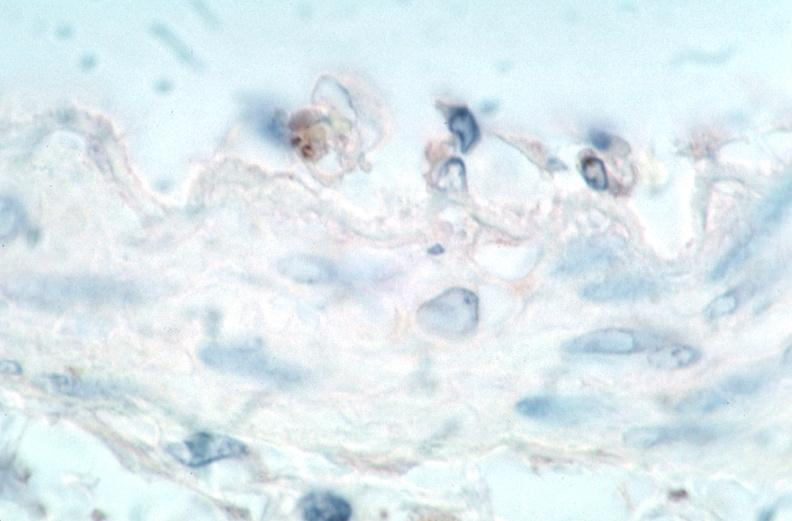what does this image show?
Answer the question using a single word or phrase. Vasculitis 